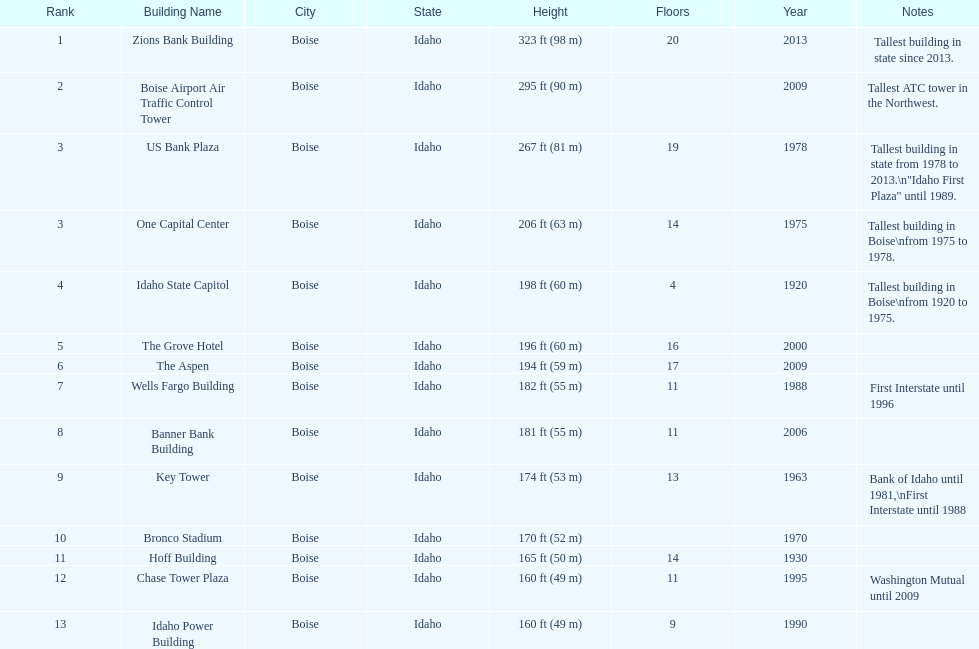How many buildings have at least ten floors? 10. 